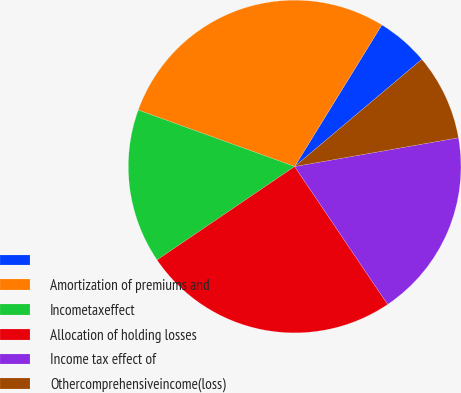Convert chart. <chart><loc_0><loc_0><loc_500><loc_500><pie_chart><ecel><fcel>Amortization of premiums and<fcel>Incometaxeffect<fcel>Allocation of holding losses<fcel>Income tax effect of<fcel>Othercomprehensiveincome(loss)<nl><fcel>5.07%<fcel>28.27%<fcel>15.01%<fcel>24.95%<fcel>18.32%<fcel>8.38%<nl></chart> 